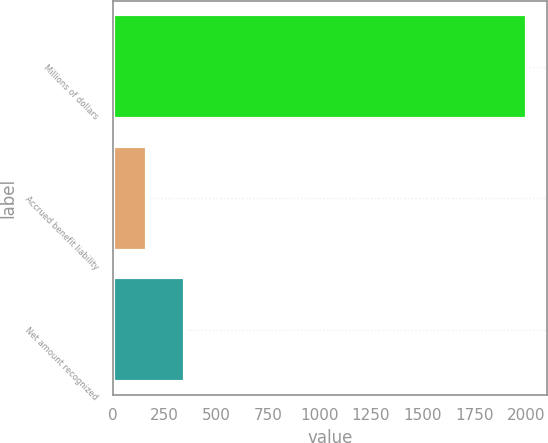Convert chart. <chart><loc_0><loc_0><loc_500><loc_500><bar_chart><fcel>Millions of dollars<fcel>Accrued benefit liability<fcel>Net amount recognized<nl><fcel>2004<fcel>166<fcel>349.8<nl></chart> 